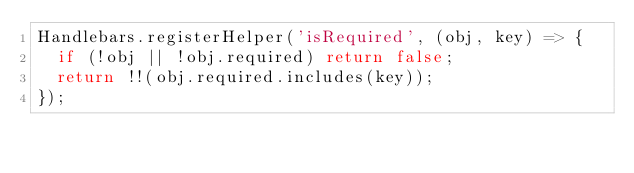Convert code to text. <code><loc_0><loc_0><loc_500><loc_500><_JavaScript_>Handlebars.registerHelper('isRequired', (obj, key) => {
  if (!obj || !obj.required) return false;
  return !!(obj.required.includes(key));
});
</code> 